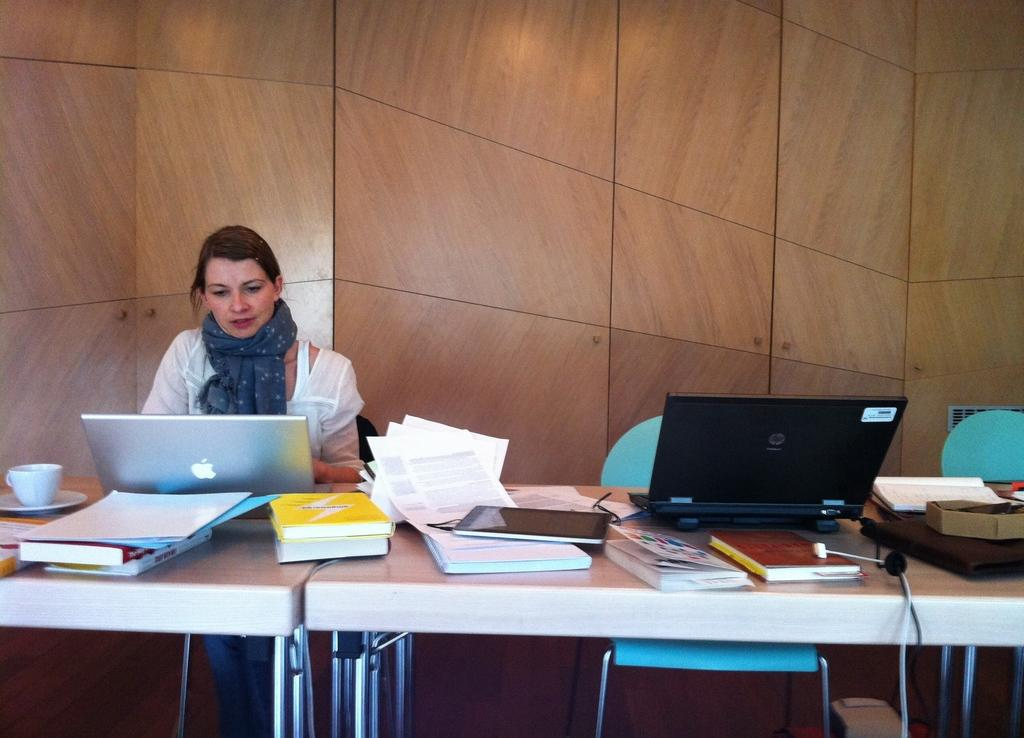What is the woman doing in the image? The woman is sitting on a chair in the image. What is located near the woman? There is a table in the image. What electronic device is on the table? There is a laptop on the table. What else can be seen on the table besides the laptop? There are books, papers, and a tablet on the table. What type of fish is swimming in the school on the table? There is no fish or school present on the table in the image. 